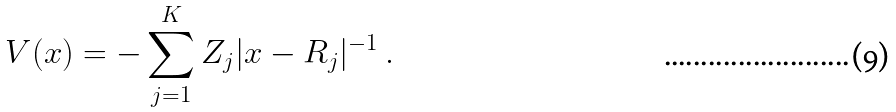Convert formula to latex. <formula><loc_0><loc_0><loc_500><loc_500>V ( x ) = - \sum _ { j = 1 } ^ { K } Z _ { j } | x - R _ { j } | ^ { - 1 } \ .</formula> 